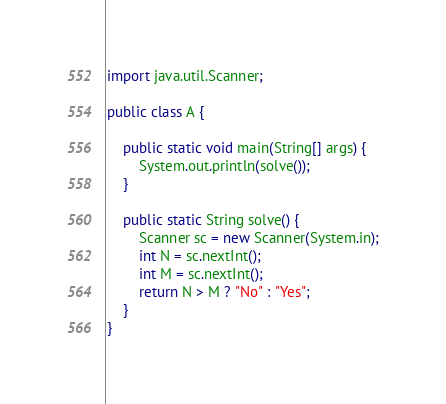<code> <loc_0><loc_0><loc_500><loc_500><_Java_>
import java.util.Scanner;

public class A {

	public static void main(String[] args) {
		System.out.println(solve());
	}
	
	public static String solve() {
		Scanner sc = new Scanner(System.in);
		int N = sc.nextInt();
		int M = sc.nextInt();
		return N > M ? "No" : "Yes";
	}
}
</code> 